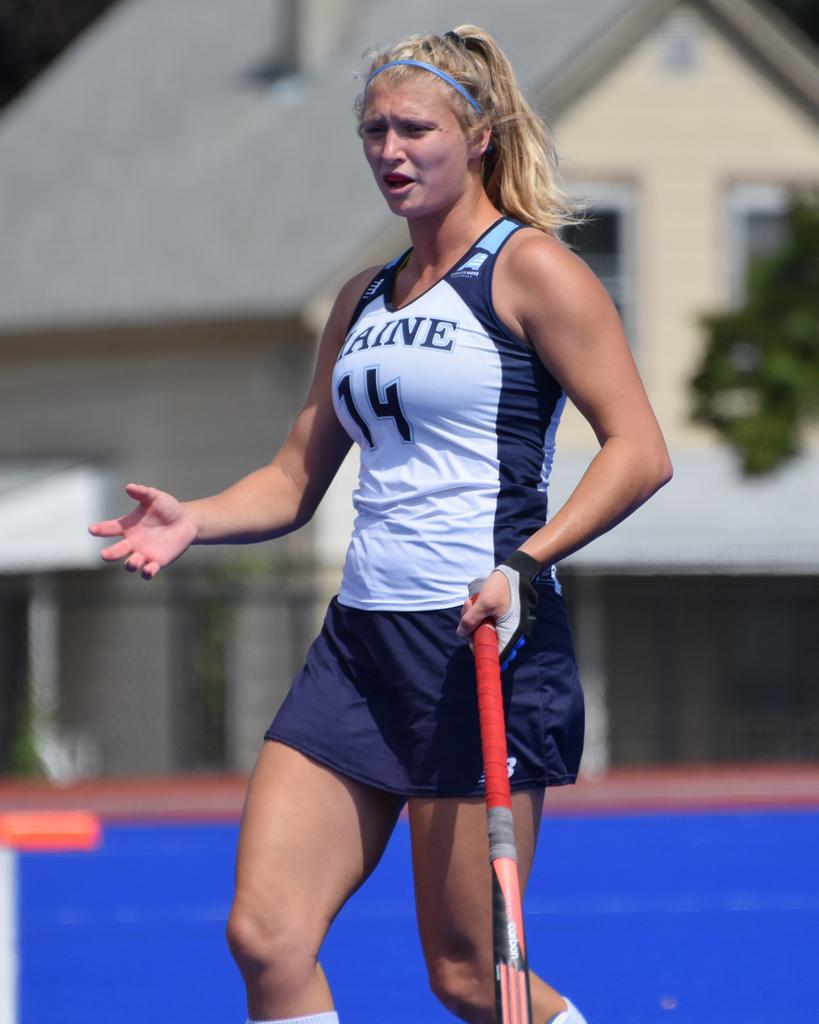<image>
Write a terse but informative summary of the picture. A female athlete for Maine wears a number 14 jersey. 